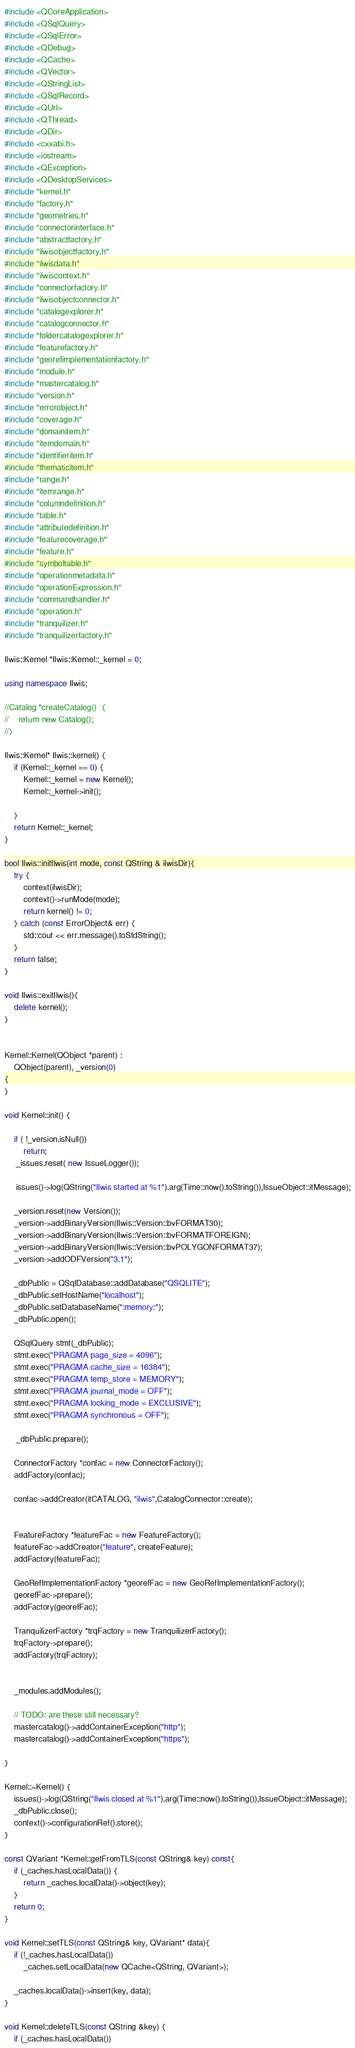Convert code to text. <code><loc_0><loc_0><loc_500><loc_500><_C++_>#include <QCoreApplication>
#include <QSqlQuery>
#include <QSqlError>
#include <QDebug>
#include <QCache>
#include <QVector>
#include <QStringList>
#include <QSqlRecord>
#include <QUrl>
#include <QThread>
#include <QDir>
#include <cxxabi.h>
#include <iostream>
#include <QException>
#include <QDesktopServices>
#include "kernel.h"
#include "factory.h"
#include "geometries.h"
#include "connectorinterface.h"
#include "abstractfactory.h"
#include "ilwisobjectfactory.h"
#include "ilwisdata.h"
#include "ilwiscontext.h"
#include "connectorfactory.h"
#include "ilwisobjectconnector.h"
#include "catalogexplorer.h"
#include "catalogconnector.h"
#include "foldercatalogexplorer.h"
#include "featurefactory.h"
#include "georefimplementationfactory.h"
#include "module.h"
#include "mastercatalog.h"
#include "version.h"
#include "errorobject.h"
#include "coverage.h"
#include "domainitem.h"
#include "itemdomain.h"
#include "identifieritem.h"
#include "thematicitem.h"
#include "range.h"
#include "itemrange.h"
#include "columndefinition.h"
#include "table.h"
#include "attributedefinition.h"
#include "featurecoverage.h"
#include "feature.h"
#include "symboltable.h"
#include "operationmetadata.h"
#include "operationExpression.h"
#include "commandhandler.h"
#include "operation.h"
#include "tranquilizer.h"
#include "tranquilizerfactory.h"

Ilwis::Kernel *Ilwis::Kernel::_kernel = 0;

using namespace Ilwis;

//Catalog *createCatalog()  {
//    return new Catalog();
//}

Ilwis::Kernel* Ilwis::kernel() {
    if (Kernel::_kernel == 0) {
        Kernel::_kernel = new Kernel();
        Kernel::_kernel->init();

    }
    return Kernel::_kernel;
}

bool Ilwis::initIlwis(int mode, const QString & ilwisDir){
    try {
        context(ilwisDir);
        context()->runMode(mode);
        return kernel() != 0;
    } catch (const ErrorObject& err) {
        std::cout << err.message().toStdString();
    }
    return false;
}

void Ilwis::exitIlwis(){
    delete kernel();
}


Kernel::Kernel(QObject *parent) :
    QObject(parent), _version(0)
{
}

void Kernel::init() {

    if ( !_version.isNull())
        return;
     _issues.reset( new IssueLogger());

     issues()->log(QString("Ilwis started at %1").arg(Time::now().toString()),IssueObject::itMessage);

    _version.reset(new Version());
    _version->addBinaryVersion(Ilwis::Version::bvFORMAT30);
    _version->addBinaryVersion(Ilwis::Version::bvFORMATFOREIGN);
    _version->addBinaryVersion(Ilwis::Version::bvPOLYGONFORMAT37);
    _version->addODFVersion("3.1");

    _dbPublic = QSqlDatabase::addDatabase("QSQLITE");
    _dbPublic.setHostName("localhost");
    _dbPublic.setDatabaseName(":memory:");
    _dbPublic.open();

    QSqlQuery stmt(_dbPublic);
    stmt.exec("PRAGMA page_size = 4096");
    stmt.exec("PRAGMA cache_size = 16384");
    stmt.exec("PRAGMA temp_store = MEMORY");
    stmt.exec("PRAGMA journal_mode = OFF");
    stmt.exec("PRAGMA locking_mode = EXCLUSIVE");
    stmt.exec("PRAGMA synchronous = OFF");

     _dbPublic.prepare();

    ConnectorFactory *confac = new ConnectorFactory();
    addFactory(confac);

    confac->addCreator(itCATALOG, "ilwis",CatalogConnector::create);


    FeatureFactory *featureFac = new FeatureFactory();
    featureFac->addCreator("feature", createFeature);
    addFactory(featureFac);

    GeoRefImplementationFactory *georefFac = new GeoRefImplementationFactory();
    georefFac->prepare();
    addFactory(georefFac);

    TranquilizerFactory *trqFactory = new TranquilizerFactory();
    trqFactory->prepare();
    addFactory(trqFactory);


    _modules.addModules();

    // TODO: are these still necessary?
    mastercatalog()->addContainerException("http");
    mastercatalog()->addContainerException("https");

}

Kernel::~Kernel() {
    issues()->log(QString("Ilwis closed at %1").arg(Time::now().toString()),IssueObject::itMessage);
    _dbPublic.close();
    context()->configurationRef().store();
}

const QVariant *Kernel::getFromTLS(const QString& key) const{
    if (_caches.hasLocalData()) {
        return _caches.localData()->object(key);
    }
    return 0;
}

void Kernel::setTLS(const QString& key, QVariant* data){
    if (!_caches.hasLocalData())
        _caches.setLocalData(new QCache<QString, QVariant>);

    _caches.localData()->insert(key, data);
}

void Kernel::deleteTLS(const QString &key) {
    if (_caches.hasLocalData())</code> 